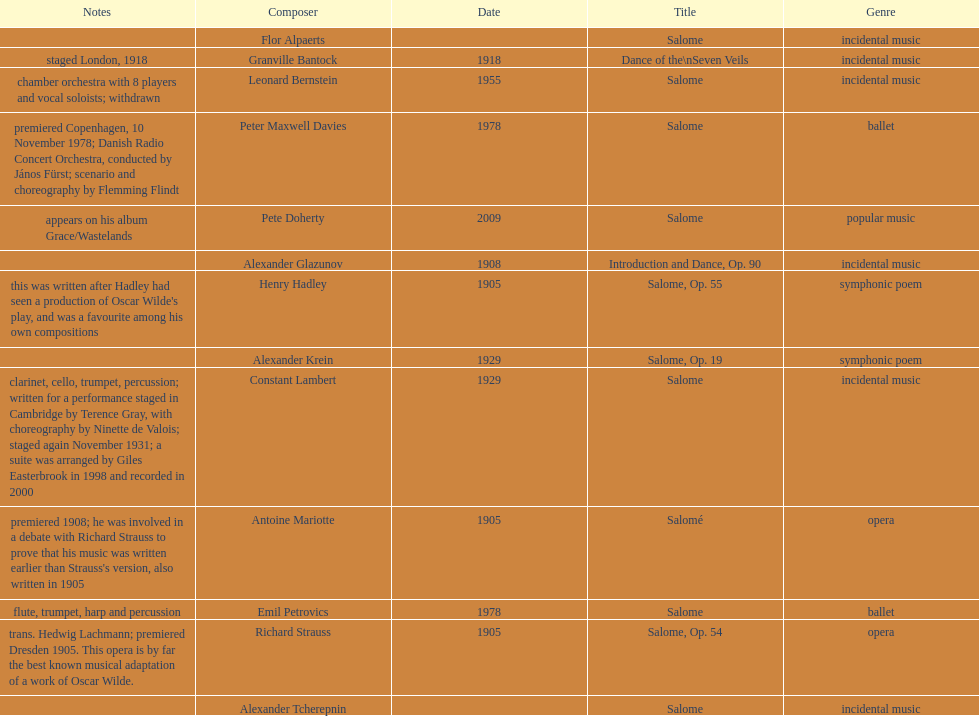Who is next on the list after alexander krein? Constant Lambert. 